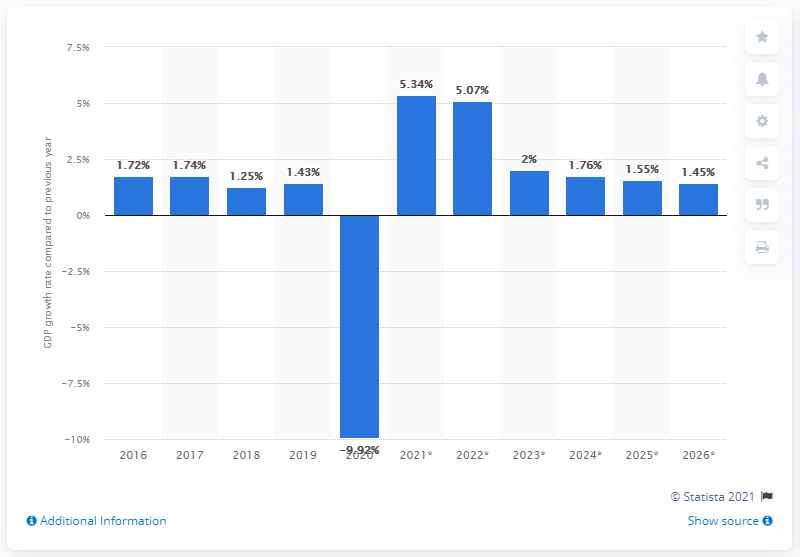Outline some significant characteristics in this image. The Gross Domestic Product (GDP) growth rate in the United Kingdom in 2019 was 1.43%. 